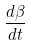<formula> <loc_0><loc_0><loc_500><loc_500>\frac { d \beta } { d t }</formula> 